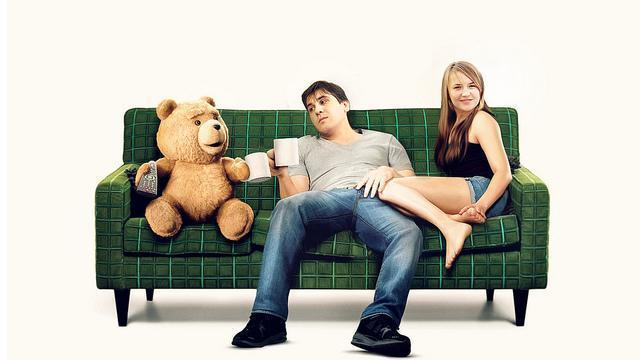How many cups are in this picture?
Give a very brief answer. 2. How many people can you see?
Give a very brief answer. 2. How many couches are there?
Give a very brief answer. 2. 